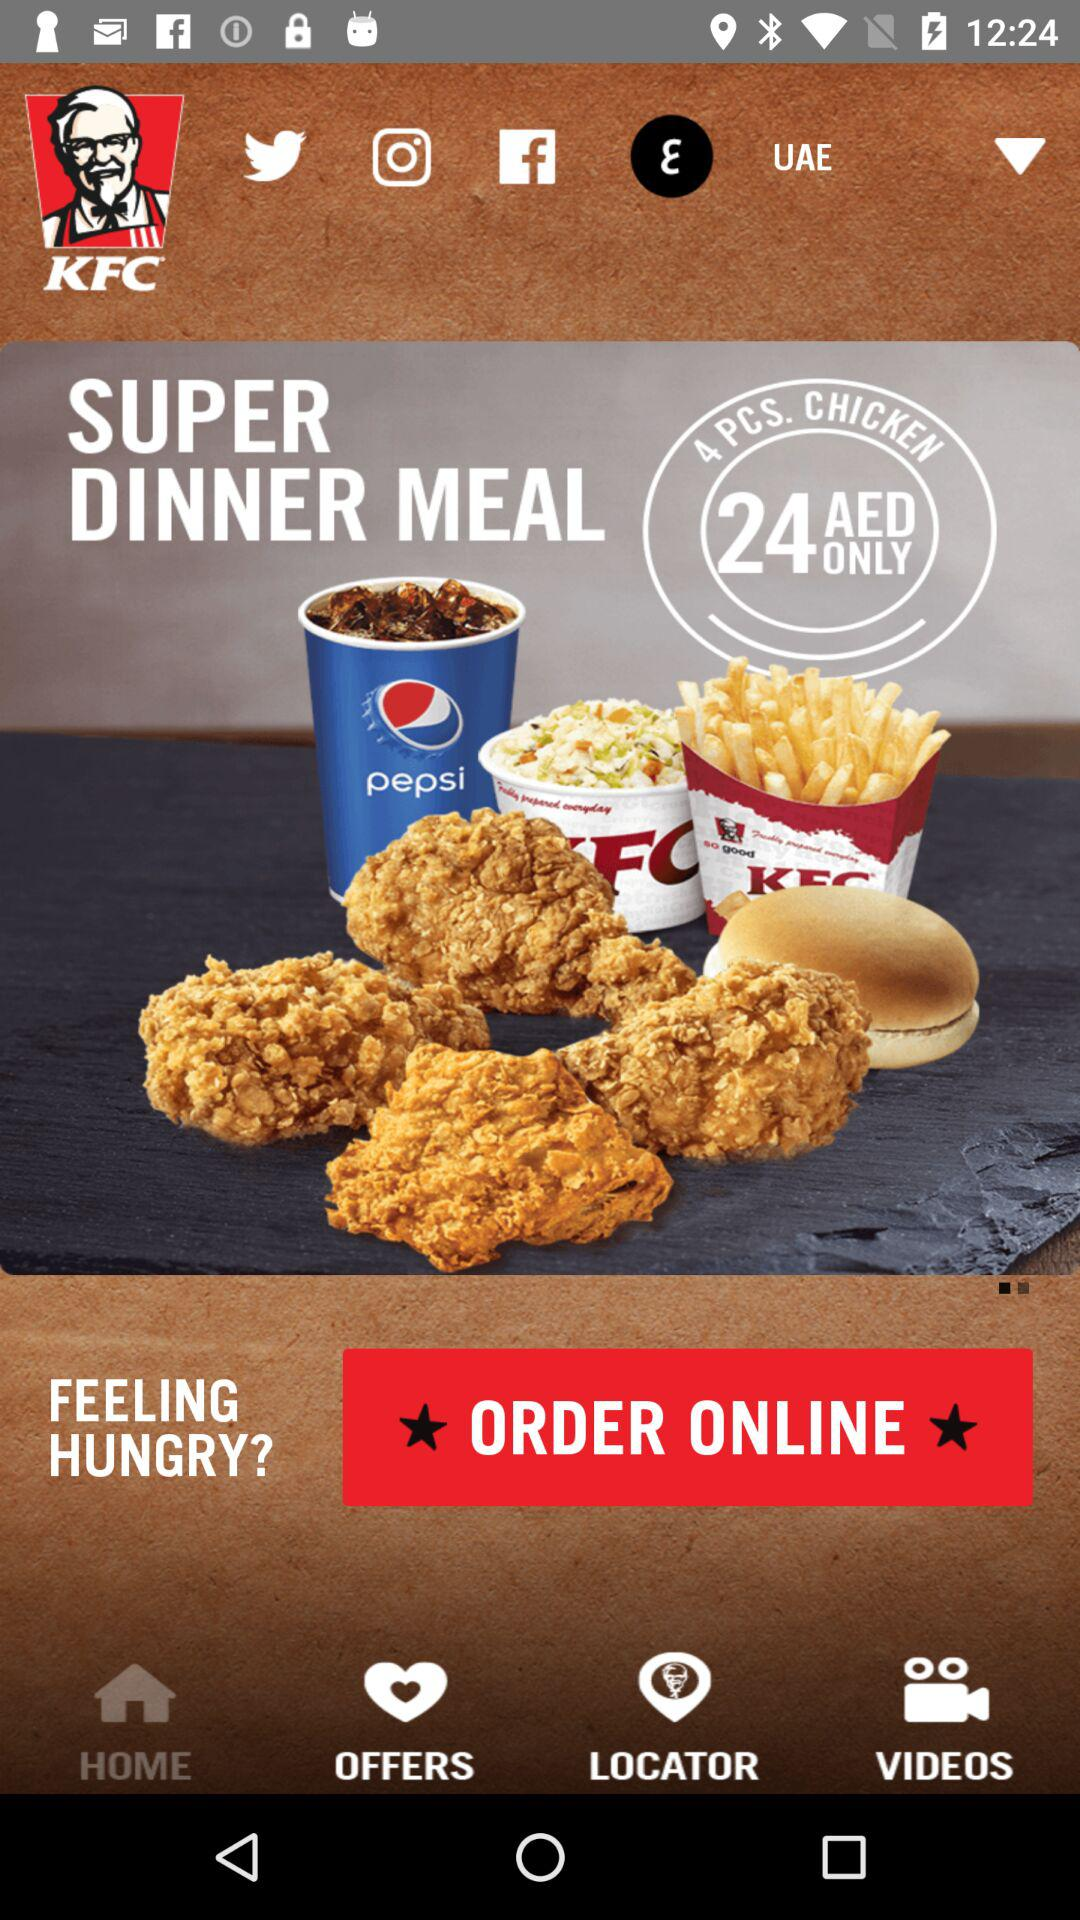What is the price for a "SUPER DINNER MEAL"? The price for a "SUPER DINNER MEAL" is 24 AED. 